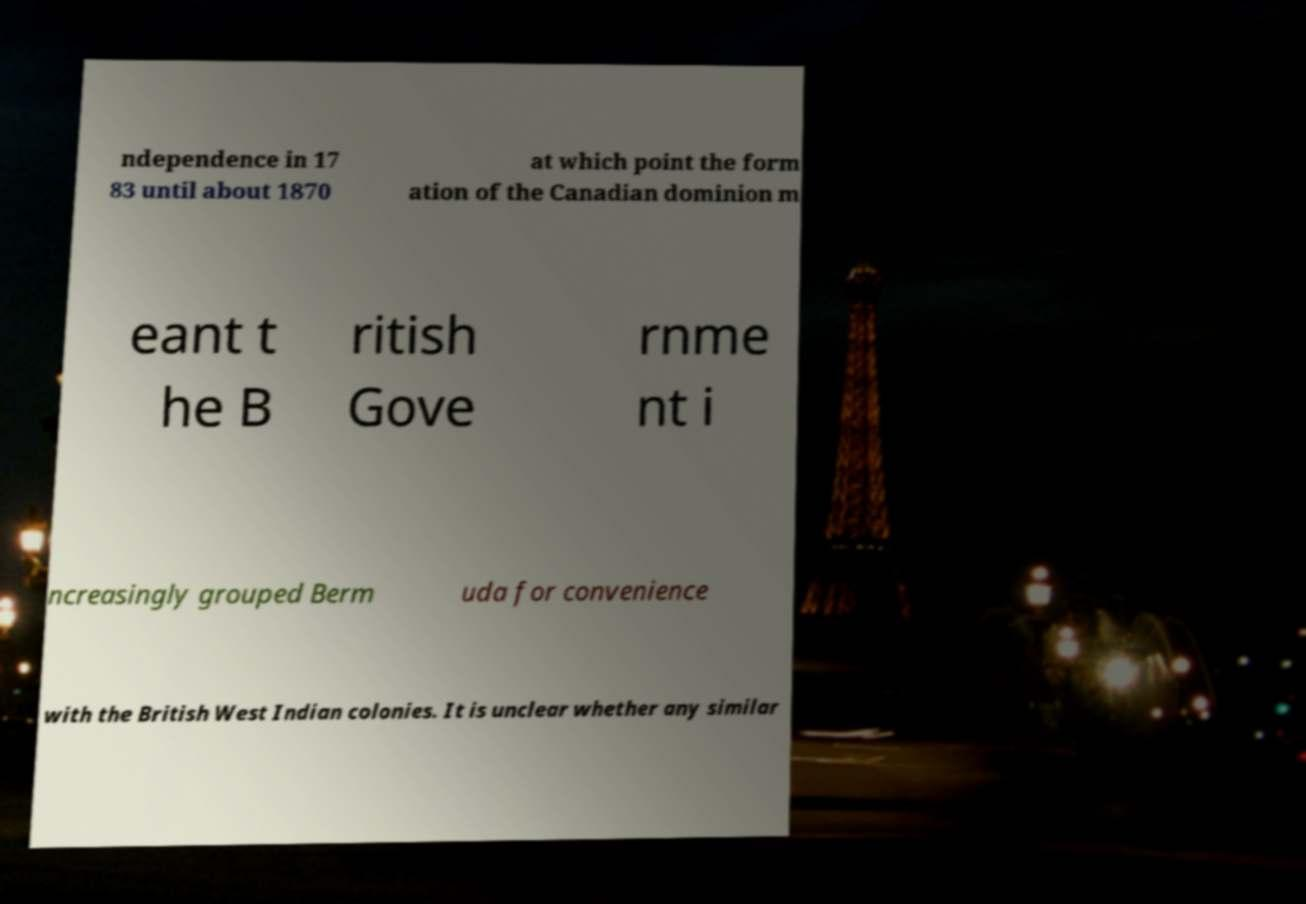Could you assist in decoding the text presented in this image and type it out clearly? ndependence in 17 83 until about 1870 at which point the form ation of the Canadian dominion m eant t he B ritish Gove rnme nt i ncreasingly grouped Berm uda for convenience with the British West Indian colonies. It is unclear whether any similar 